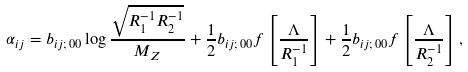<formula> <loc_0><loc_0><loc_500><loc_500>\alpha _ { i j } = b _ { i j ; \, 0 0 } \log \frac { \sqrt { R _ { 1 } ^ { - 1 } R _ { 2 } ^ { - 1 } } } { M _ { Z } } + \frac { 1 } { 2 } b _ { i j ; \, 0 0 } f \left [ \frac { \Lambda } { R _ { 1 } ^ { - 1 } } \right ] + \frac { 1 } { 2 } b _ { i j ; \, 0 0 } f \left [ \frac { \Lambda } { R _ { 2 } ^ { - 1 } } \right ] ,</formula> 